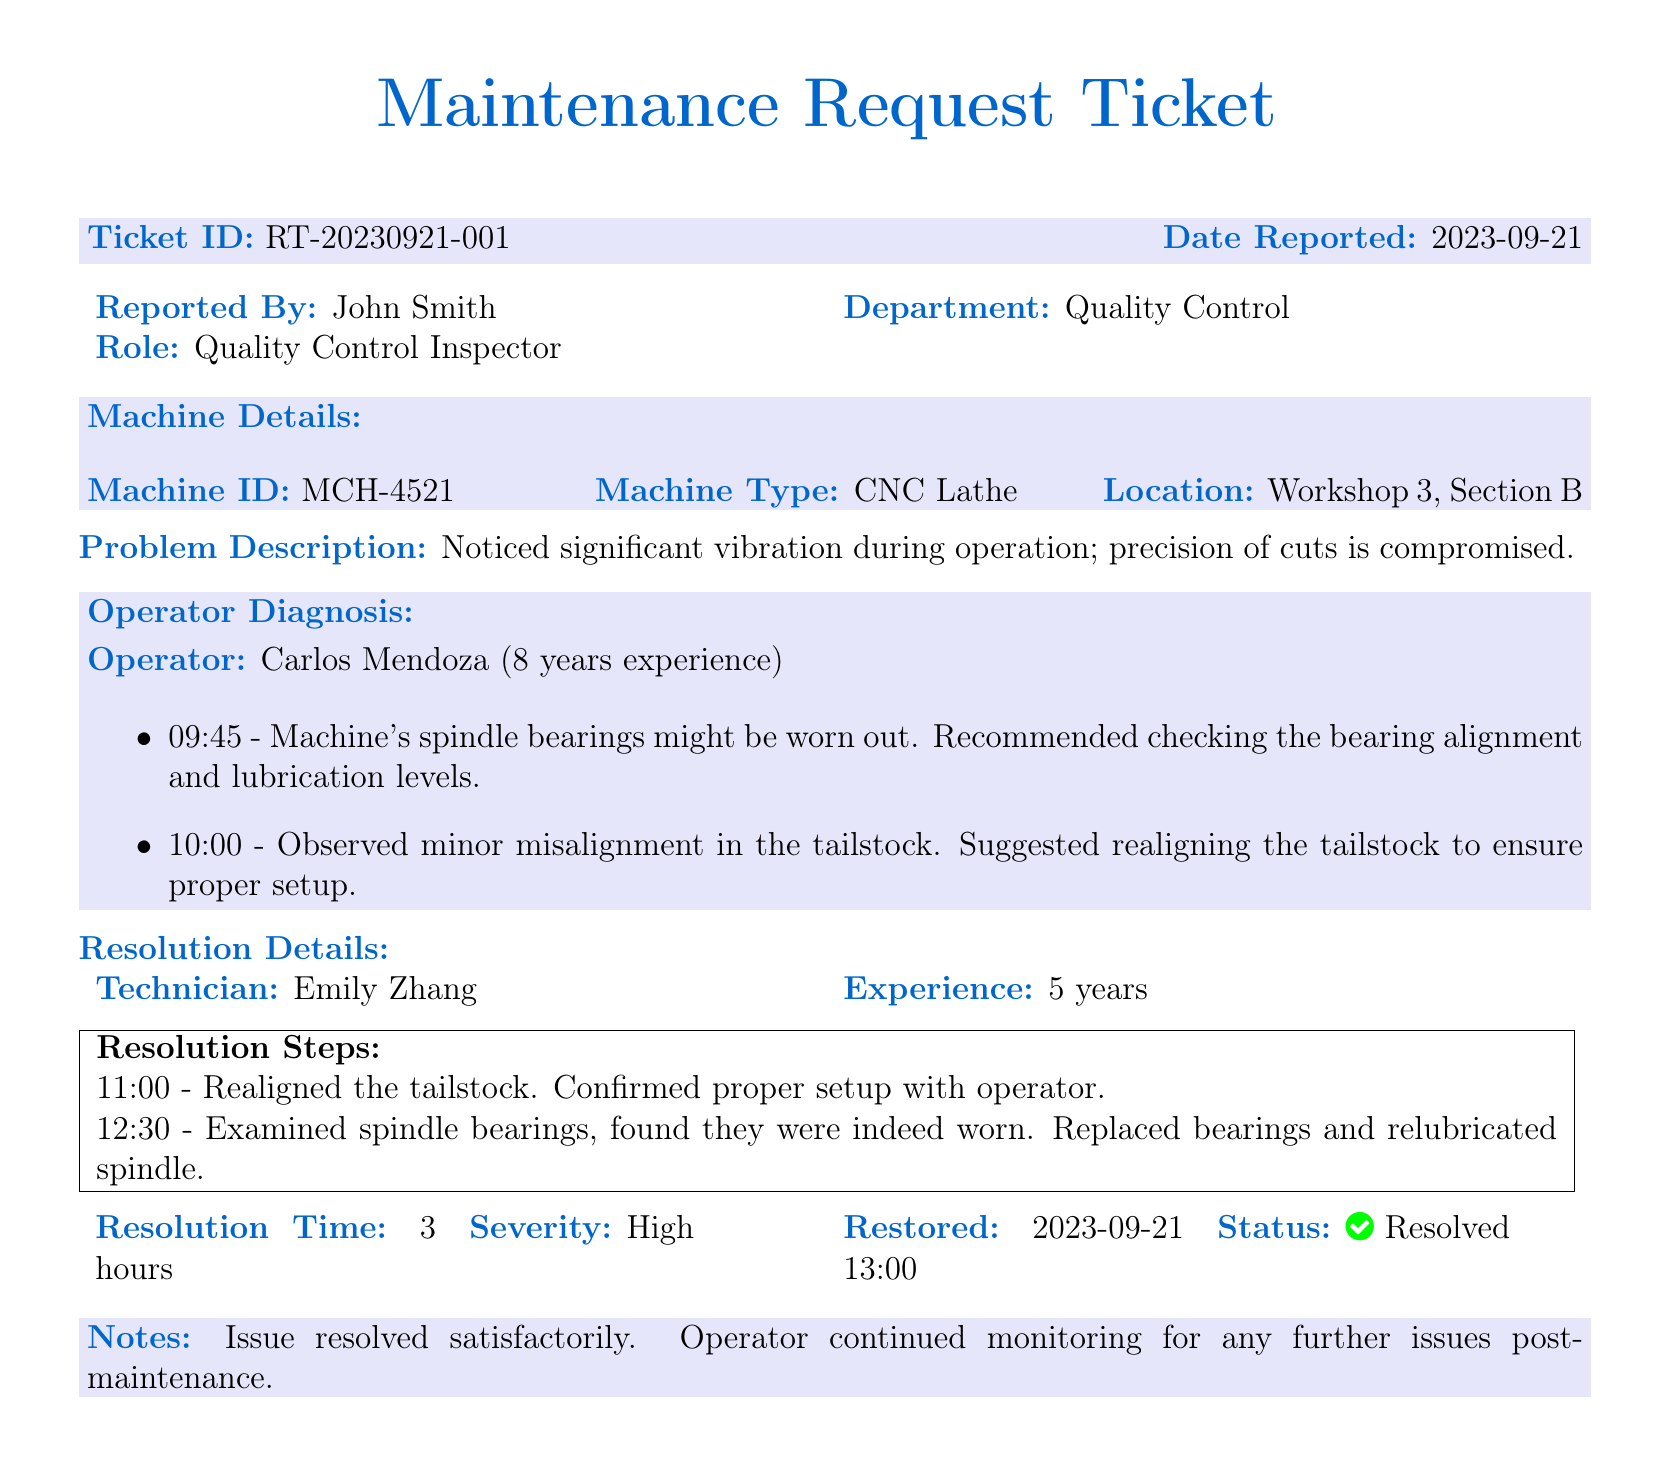What is the Ticket ID? The Ticket ID is a unique identifier for this maintenance request found at the top of the document.
Answer: RT-20230921-001 Who reported the issue? The person who reported the issue is listed in the document under 'Reported By'.
Answer: John Smith What machine type is involved? The machine type is specified in the 'Machine Details' section of the document.
Answer: CNC Lathe What was the first operator diagnosis time? The document indicates multiple operator diagnoses with specific times noted next to each.
Answer: 09:45 What was the resolution time? The resolution time is stated in the section detailing the resolution details of the ticket.
Answer: 3 hours What was the technician's name? The technician who worked on the maintenance request is mentioned in the resolution details.
Answer: Emily Zhang What issue was observed during operation? The problem description section outlines the main issue identified with the machine.
Answer: Significant vibration What is the severity of the issue? The severity level of the issue is categorized in the resolution details section of the ticket.
Answer: High What was done at 12:30? The resolution details include timestamps for each step taken during maintenance.
Answer: Replaced bearings and relubricated spindle 